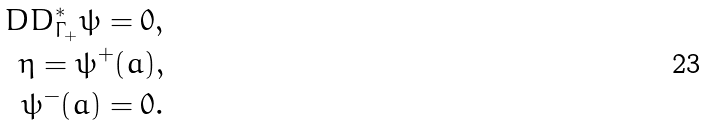<formula> <loc_0><loc_0><loc_500><loc_500>\ D D _ { \Gamma _ { + } } ^ { * } \psi = 0 , \\ \eta = \psi ^ { + } ( a ) , \\ \psi ^ { - } ( a ) = 0 .</formula> 